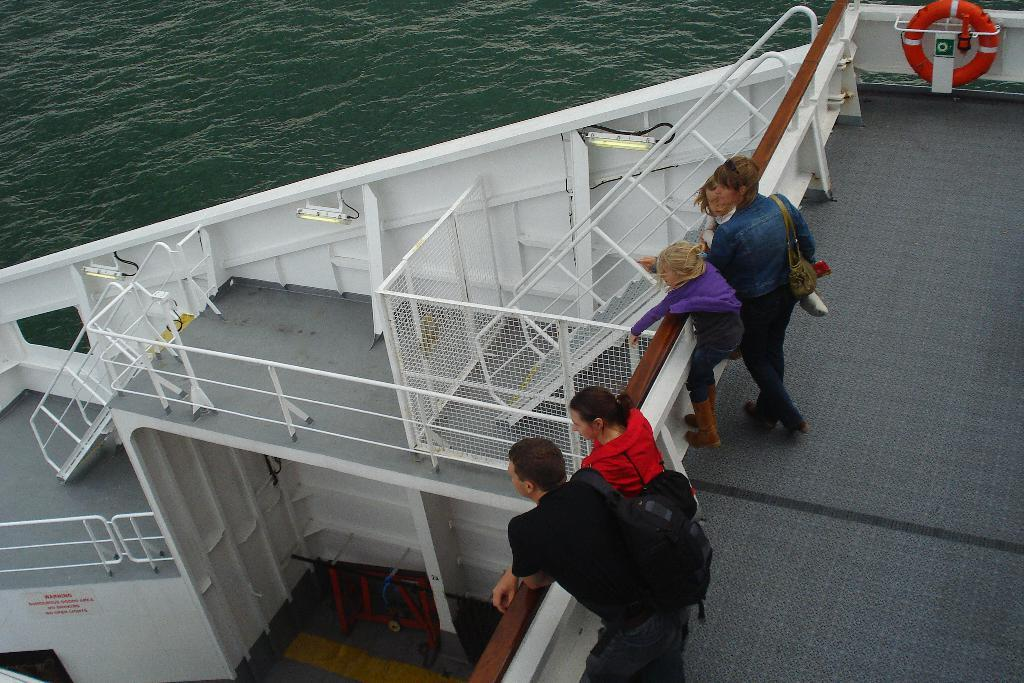What is the main subject of the picture? The main subject of the picture is a ship. What is the color of the ship? The ship is white in color. Are there any specific features on the ship? Yes, the ship has railings. What can be found on the ship? There is a mat on the ship. Are there any people on the ship? Yes, there are people on the ship. What else can be seen on the ship? There is water visible inside the ship. What type of boot can be seen on the ship in the image? There is no boot visible in the image; it features a white ship with railings, a mat, people, and water inside. How does the temper of the people on the ship affect the ship's movement? There is no information about the temper of the people on the ship, and their temper does not affect the ship's movement. 